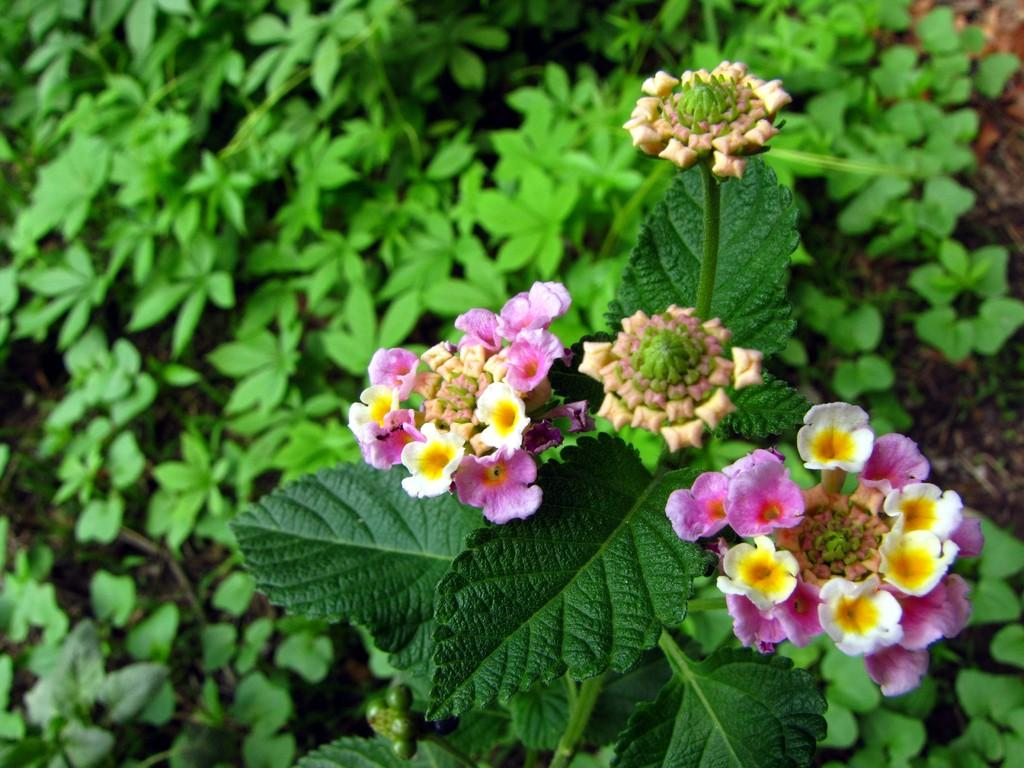Where was the picture taken? The picture was taken outside. What can be seen on the right side of the image? There are flowers and a plant on the right side of the image. What is visible in the background of the image? There is ground and plants visible in the background of the image. What type of society is depicted in the image? There is no society depicted in the image; it features flowers, plants, and an outdoor setting. What scene is taking place in the image? The image does not depict a specific scene; it simply shows an outdoor area with flowers, plants, and ground visible in the background. 